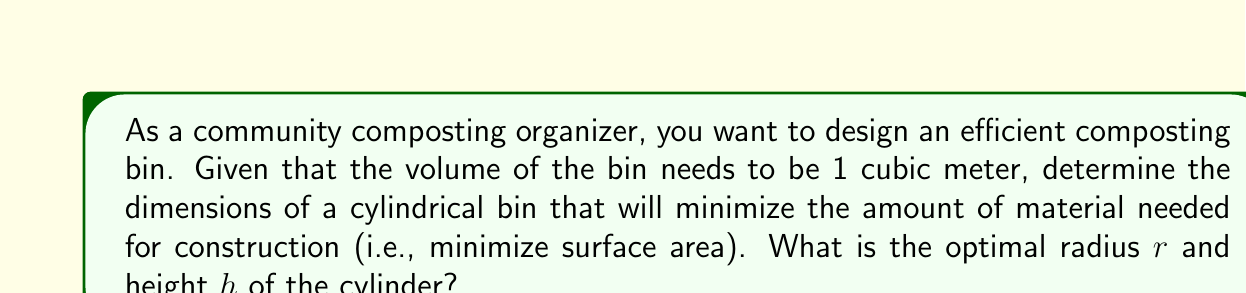Help me with this question. Let's approach this step-by-step:

1) The volume of a cylinder is given by $V = \pi r^2 h$, where $r$ is the radius and $h$ is the height.

2) The surface area of a cylinder (including top and bottom) is $S = 2\pi r^2 + 2\pi rh$.

3) We're given that the volume is 1 cubic meter, so:

   $$\pi r^2 h = 1$$
   
   $$h = \frac{1}{\pi r^2}$$

4) Substitute this into the surface area formula:

   $$S = 2\pi r^2 + 2\pi r(\frac{1}{\pi r^2}) = 2\pi r^2 + \frac{2}{r}$$

5) To find the minimum, we differentiate $S$ with respect to $r$ and set it to zero:

   $$\frac{dS}{dr} = 4\pi r - \frac{2}{r^2} = 0$$

6) Solve this equation:

   $$4\pi r^3 = 2$$
   $$r^3 = \frac{1}{2\pi}$$
   $$r = \sqrt[3]{\frac{1}{2\pi}} \approx 0.54$$

7) Now we can find $h$ using the volume equation:

   $$h = \frac{1}{\pi r^2} = \frac{1}{\pi (\frac{1}{2\pi})^{2/3}} = \sqrt[3]{\frac{4\pi}{2}} \approx 1.08$$

Therefore, the optimal dimensions are $r \approx 0.54$ m and $h \approx 1.08$ m.
Answer: $r \approx 0.54$ m, $h \approx 1.08$ m 